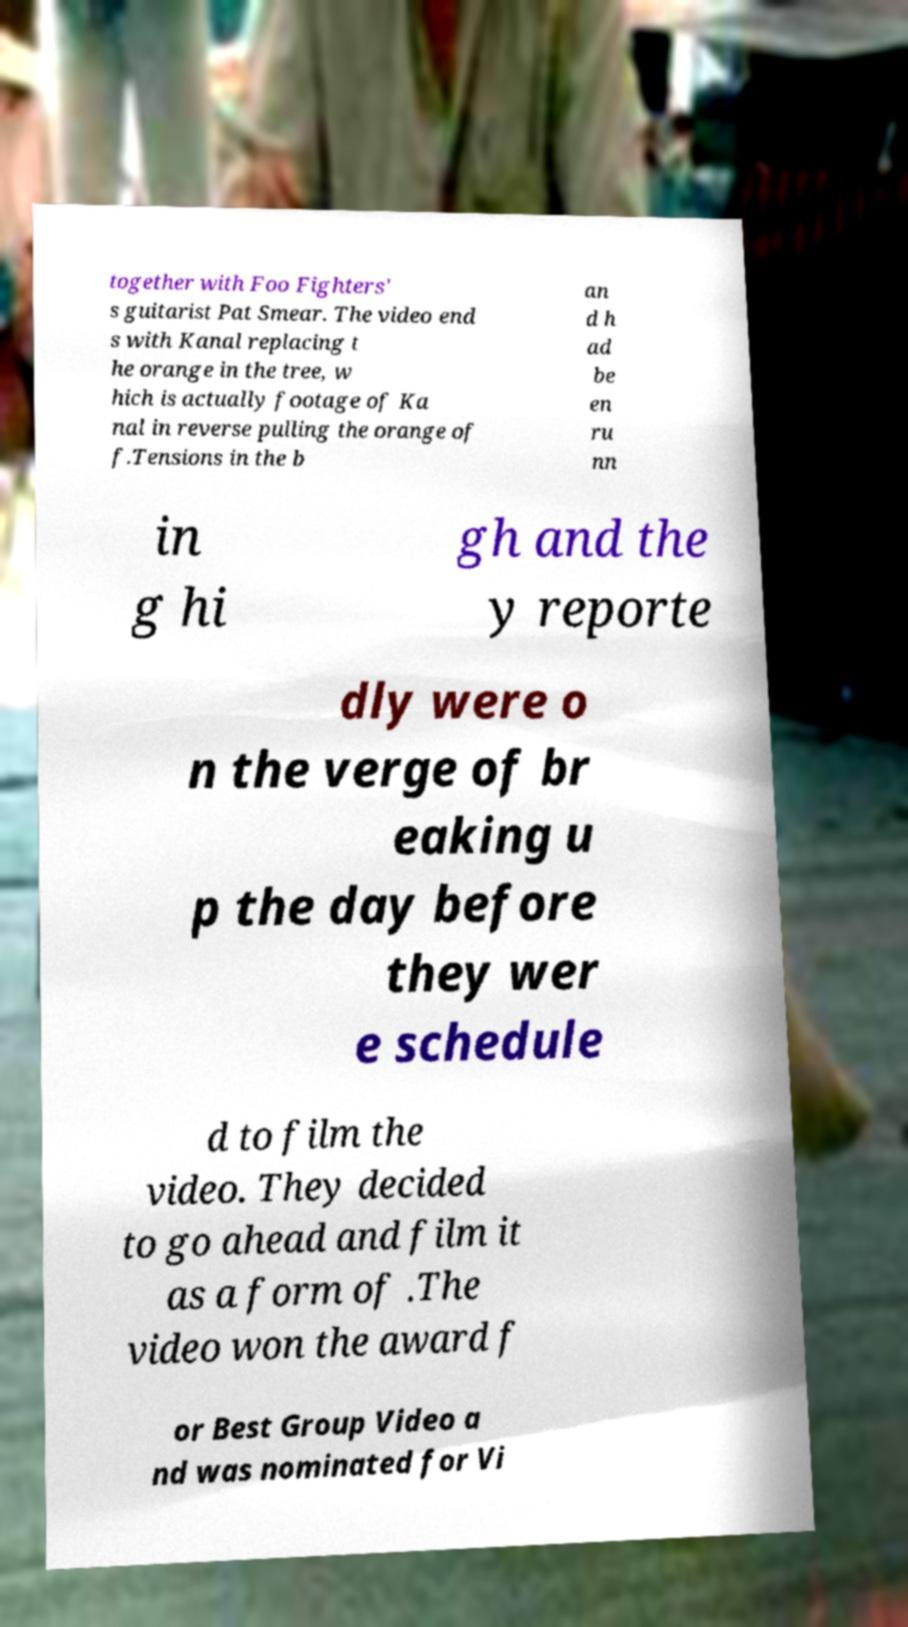Could you assist in decoding the text presented in this image and type it out clearly? together with Foo Fighters' s guitarist Pat Smear. The video end s with Kanal replacing t he orange in the tree, w hich is actually footage of Ka nal in reverse pulling the orange of f.Tensions in the b an d h ad be en ru nn in g hi gh and the y reporte dly were o n the verge of br eaking u p the day before they wer e schedule d to film the video. They decided to go ahead and film it as a form of .The video won the award f or Best Group Video a nd was nominated for Vi 